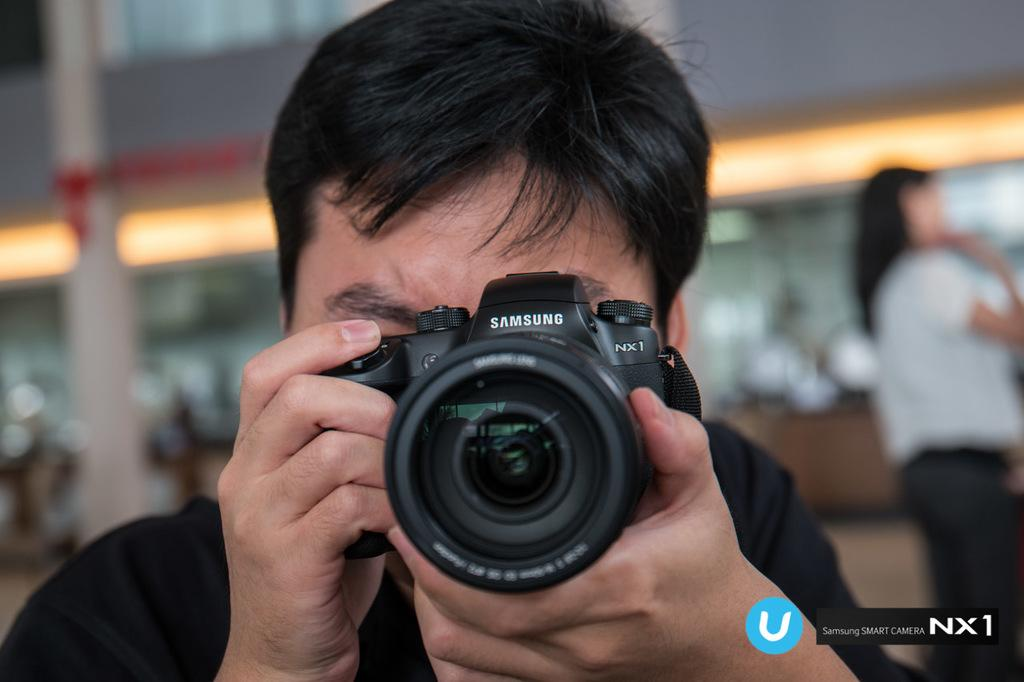What is the man in the image doing? The man is holding a camera in front of his face. What is the man wearing in the image? The man is wearing a black t-shirt. Who else is present in the image? There is a woman in the image. What is the woman wearing in the image? The woman is wearing a white dress. Where is the woman located in the image? The woman is located in the right corner of the image. Can you see any clovers in the image? There are no clovers present in the image. What type of party is being held in the image? There is no party depicted in the image. 